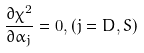<formula> <loc_0><loc_0><loc_500><loc_500>\frac { \partial \chi ^ { 2 } } { \partial \alpha _ { j } } = 0 , ( j = D , S )</formula> 